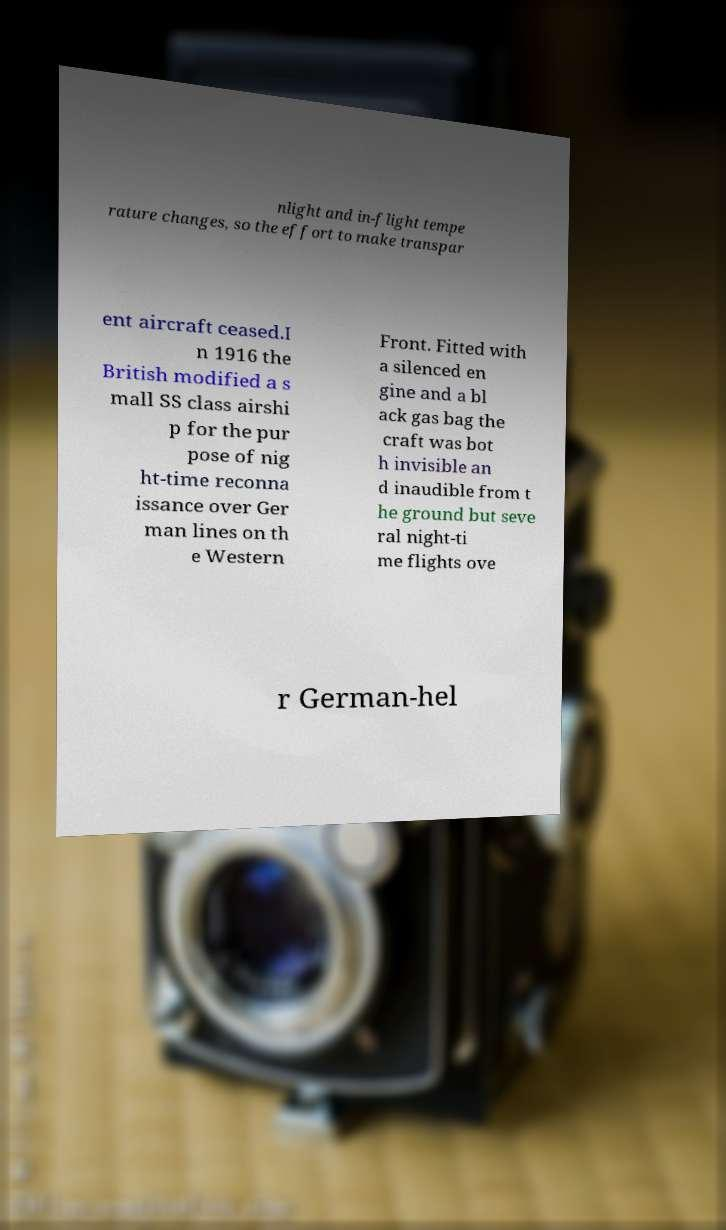What messages or text are displayed in this image? I need them in a readable, typed format. nlight and in-flight tempe rature changes, so the effort to make transpar ent aircraft ceased.I n 1916 the British modified a s mall SS class airshi p for the pur pose of nig ht-time reconna issance over Ger man lines on th e Western Front. Fitted with a silenced en gine and a bl ack gas bag the craft was bot h invisible an d inaudible from t he ground but seve ral night-ti me flights ove r German-hel 